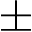<formula> <loc_0><loc_0><loc_500><loc_500>\pm</formula> 